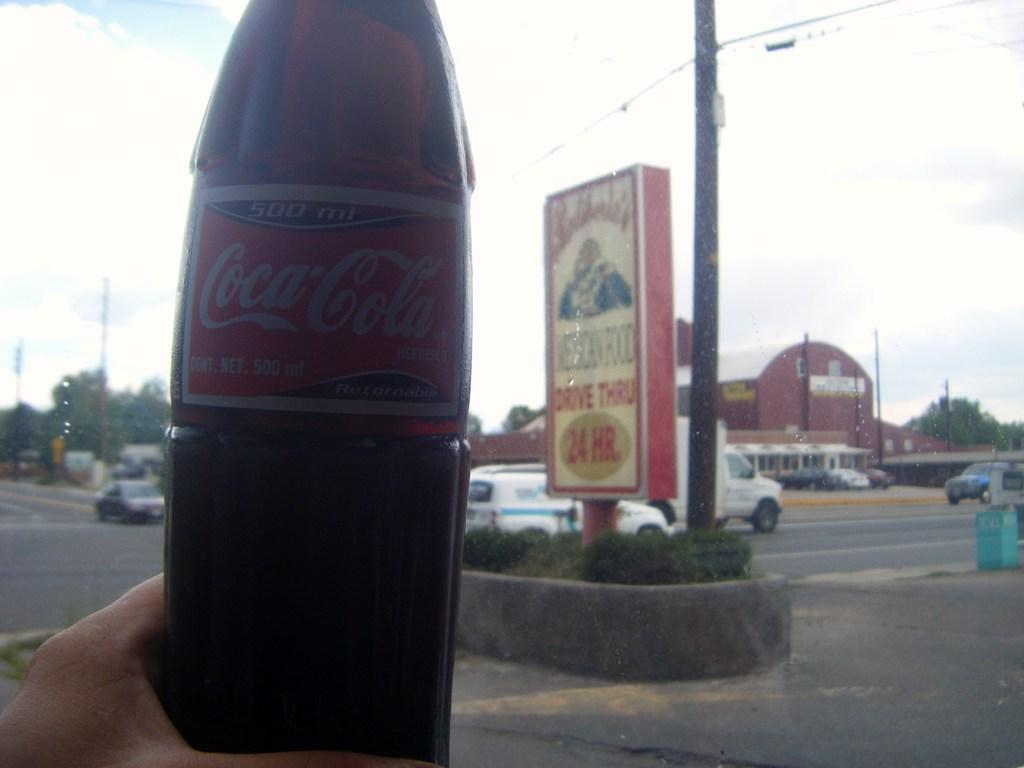Provide a one-sentence caption for the provided image. Person holding a glass bottle of a Coca Cola. 